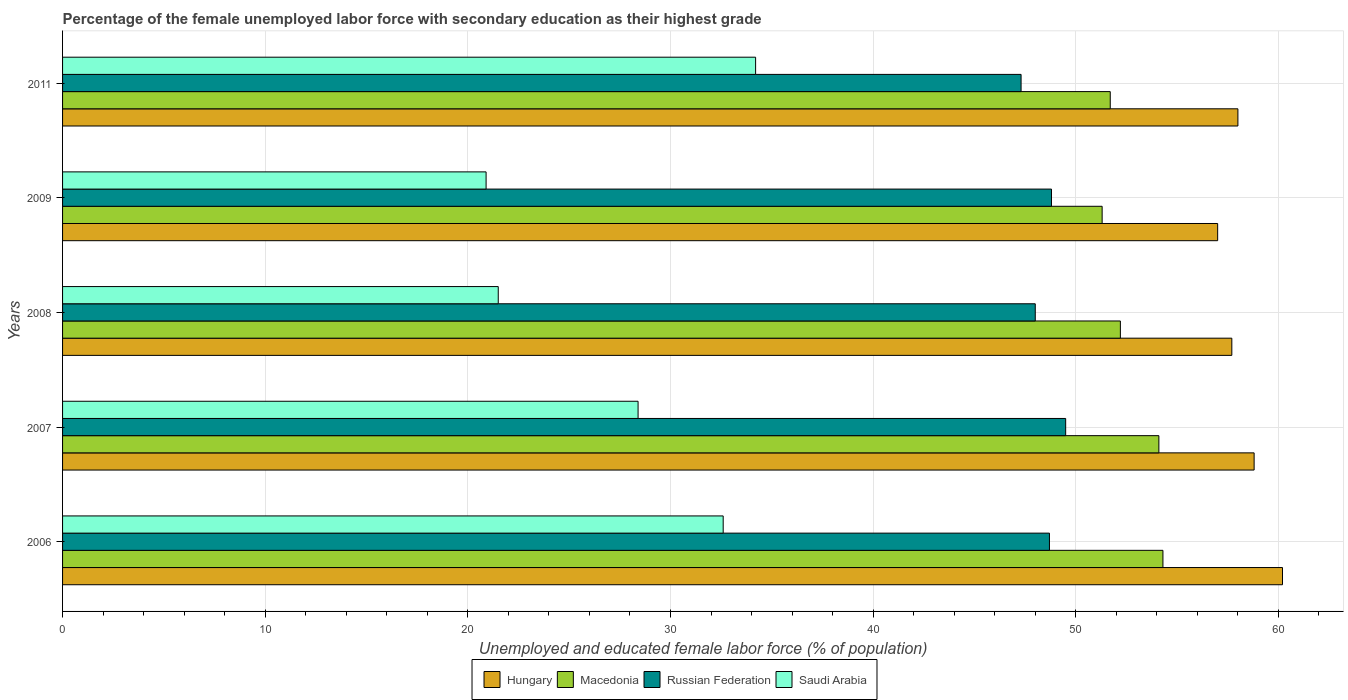How many different coloured bars are there?
Your answer should be very brief. 4. How many groups of bars are there?
Provide a succinct answer. 5. How many bars are there on the 5th tick from the top?
Your answer should be compact. 4. What is the label of the 4th group of bars from the top?
Give a very brief answer. 2007. What is the percentage of the unemployed female labor force with secondary education in Macedonia in 2011?
Your response must be concise. 51.7. Across all years, what is the maximum percentage of the unemployed female labor force with secondary education in Hungary?
Provide a succinct answer. 60.2. Across all years, what is the minimum percentage of the unemployed female labor force with secondary education in Macedonia?
Your answer should be very brief. 51.3. In which year was the percentage of the unemployed female labor force with secondary education in Hungary maximum?
Your answer should be compact. 2006. What is the total percentage of the unemployed female labor force with secondary education in Hungary in the graph?
Offer a terse response. 291.7. What is the difference between the percentage of the unemployed female labor force with secondary education in Russian Federation in 2008 and that in 2009?
Make the answer very short. -0.8. What is the difference between the percentage of the unemployed female labor force with secondary education in Saudi Arabia in 2006 and the percentage of the unemployed female labor force with secondary education in Hungary in 2008?
Offer a very short reply. -25.1. What is the average percentage of the unemployed female labor force with secondary education in Russian Federation per year?
Your answer should be compact. 48.46. In the year 2007, what is the difference between the percentage of the unemployed female labor force with secondary education in Russian Federation and percentage of the unemployed female labor force with secondary education in Saudi Arabia?
Your answer should be very brief. 21.1. What is the ratio of the percentage of the unemployed female labor force with secondary education in Saudi Arabia in 2006 to that in 2007?
Your answer should be very brief. 1.15. What is the difference between the highest and the second highest percentage of the unemployed female labor force with secondary education in Macedonia?
Provide a succinct answer. 0.2. What is the difference between the highest and the lowest percentage of the unemployed female labor force with secondary education in Saudi Arabia?
Make the answer very short. 13.3. In how many years, is the percentage of the unemployed female labor force with secondary education in Saudi Arabia greater than the average percentage of the unemployed female labor force with secondary education in Saudi Arabia taken over all years?
Make the answer very short. 3. Is it the case that in every year, the sum of the percentage of the unemployed female labor force with secondary education in Saudi Arabia and percentage of the unemployed female labor force with secondary education in Russian Federation is greater than the sum of percentage of the unemployed female labor force with secondary education in Hungary and percentage of the unemployed female labor force with secondary education in Macedonia?
Keep it short and to the point. Yes. What does the 2nd bar from the top in 2007 represents?
Your answer should be compact. Russian Federation. What does the 4th bar from the bottom in 2006 represents?
Offer a terse response. Saudi Arabia. What is the difference between two consecutive major ticks on the X-axis?
Ensure brevity in your answer.  10. Are the values on the major ticks of X-axis written in scientific E-notation?
Offer a very short reply. No. Does the graph contain any zero values?
Your answer should be very brief. No. Does the graph contain grids?
Ensure brevity in your answer.  Yes. Where does the legend appear in the graph?
Provide a short and direct response. Bottom center. How many legend labels are there?
Ensure brevity in your answer.  4. How are the legend labels stacked?
Your answer should be compact. Horizontal. What is the title of the graph?
Your answer should be compact. Percentage of the female unemployed labor force with secondary education as their highest grade. What is the label or title of the X-axis?
Keep it short and to the point. Unemployed and educated female labor force (% of population). What is the label or title of the Y-axis?
Ensure brevity in your answer.  Years. What is the Unemployed and educated female labor force (% of population) in Hungary in 2006?
Keep it short and to the point. 60.2. What is the Unemployed and educated female labor force (% of population) in Macedonia in 2006?
Keep it short and to the point. 54.3. What is the Unemployed and educated female labor force (% of population) in Russian Federation in 2006?
Give a very brief answer. 48.7. What is the Unemployed and educated female labor force (% of population) of Saudi Arabia in 2006?
Your answer should be compact. 32.6. What is the Unemployed and educated female labor force (% of population) in Hungary in 2007?
Your answer should be very brief. 58.8. What is the Unemployed and educated female labor force (% of population) in Macedonia in 2007?
Your response must be concise. 54.1. What is the Unemployed and educated female labor force (% of population) in Russian Federation in 2007?
Offer a terse response. 49.5. What is the Unemployed and educated female labor force (% of population) in Saudi Arabia in 2007?
Make the answer very short. 28.4. What is the Unemployed and educated female labor force (% of population) in Hungary in 2008?
Your answer should be compact. 57.7. What is the Unemployed and educated female labor force (% of population) of Macedonia in 2008?
Make the answer very short. 52.2. What is the Unemployed and educated female labor force (% of population) of Saudi Arabia in 2008?
Give a very brief answer. 21.5. What is the Unemployed and educated female labor force (% of population) of Macedonia in 2009?
Give a very brief answer. 51.3. What is the Unemployed and educated female labor force (% of population) in Russian Federation in 2009?
Your answer should be compact. 48.8. What is the Unemployed and educated female labor force (% of population) in Saudi Arabia in 2009?
Your answer should be very brief. 20.9. What is the Unemployed and educated female labor force (% of population) of Macedonia in 2011?
Give a very brief answer. 51.7. What is the Unemployed and educated female labor force (% of population) of Russian Federation in 2011?
Give a very brief answer. 47.3. What is the Unemployed and educated female labor force (% of population) of Saudi Arabia in 2011?
Provide a short and direct response. 34.2. Across all years, what is the maximum Unemployed and educated female labor force (% of population) in Hungary?
Give a very brief answer. 60.2. Across all years, what is the maximum Unemployed and educated female labor force (% of population) in Macedonia?
Ensure brevity in your answer.  54.3. Across all years, what is the maximum Unemployed and educated female labor force (% of population) of Russian Federation?
Your response must be concise. 49.5. Across all years, what is the maximum Unemployed and educated female labor force (% of population) in Saudi Arabia?
Make the answer very short. 34.2. Across all years, what is the minimum Unemployed and educated female labor force (% of population) of Macedonia?
Provide a short and direct response. 51.3. Across all years, what is the minimum Unemployed and educated female labor force (% of population) in Russian Federation?
Your answer should be compact. 47.3. Across all years, what is the minimum Unemployed and educated female labor force (% of population) of Saudi Arabia?
Give a very brief answer. 20.9. What is the total Unemployed and educated female labor force (% of population) in Hungary in the graph?
Ensure brevity in your answer.  291.7. What is the total Unemployed and educated female labor force (% of population) in Macedonia in the graph?
Your answer should be very brief. 263.6. What is the total Unemployed and educated female labor force (% of population) of Russian Federation in the graph?
Your answer should be very brief. 242.3. What is the total Unemployed and educated female labor force (% of population) in Saudi Arabia in the graph?
Offer a very short reply. 137.6. What is the difference between the Unemployed and educated female labor force (% of population) in Saudi Arabia in 2006 and that in 2007?
Keep it short and to the point. 4.2. What is the difference between the Unemployed and educated female labor force (% of population) in Hungary in 2006 and that in 2008?
Ensure brevity in your answer.  2.5. What is the difference between the Unemployed and educated female labor force (% of population) of Saudi Arabia in 2006 and that in 2008?
Provide a succinct answer. 11.1. What is the difference between the Unemployed and educated female labor force (% of population) of Hungary in 2006 and that in 2009?
Offer a very short reply. 3.2. What is the difference between the Unemployed and educated female labor force (% of population) in Russian Federation in 2006 and that in 2009?
Your response must be concise. -0.1. What is the difference between the Unemployed and educated female labor force (% of population) in Saudi Arabia in 2006 and that in 2009?
Ensure brevity in your answer.  11.7. What is the difference between the Unemployed and educated female labor force (% of population) of Hungary in 2006 and that in 2011?
Provide a short and direct response. 2.2. What is the difference between the Unemployed and educated female labor force (% of population) in Macedonia in 2007 and that in 2008?
Provide a short and direct response. 1.9. What is the difference between the Unemployed and educated female labor force (% of population) in Saudi Arabia in 2007 and that in 2008?
Your response must be concise. 6.9. What is the difference between the Unemployed and educated female labor force (% of population) in Hungary in 2007 and that in 2009?
Make the answer very short. 1.8. What is the difference between the Unemployed and educated female labor force (% of population) in Russian Federation in 2007 and that in 2009?
Your answer should be very brief. 0.7. What is the difference between the Unemployed and educated female labor force (% of population) of Russian Federation in 2007 and that in 2011?
Offer a terse response. 2.2. What is the difference between the Unemployed and educated female labor force (% of population) in Macedonia in 2008 and that in 2009?
Offer a terse response. 0.9. What is the difference between the Unemployed and educated female labor force (% of population) in Russian Federation in 2008 and that in 2009?
Make the answer very short. -0.8. What is the difference between the Unemployed and educated female labor force (% of population) of Macedonia in 2008 and that in 2011?
Ensure brevity in your answer.  0.5. What is the difference between the Unemployed and educated female labor force (% of population) in Saudi Arabia in 2008 and that in 2011?
Provide a short and direct response. -12.7. What is the difference between the Unemployed and educated female labor force (% of population) in Hungary in 2006 and the Unemployed and educated female labor force (% of population) in Macedonia in 2007?
Offer a terse response. 6.1. What is the difference between the Unemployed and educated female labor force (% of population) of Hungary in 2006 and the Unemployed and educated female labor force (% of population) of Russian Federation in 2007?
Give a very brief answer. 10.7. What is the difference between the Unemployed and educated female labor force (% of population) of Hungary in 2006 and the Unemployed and educated female labor force (% of population) of Saudi Arabia in 2007?
Keep it short and to the point. 31.8. What is the difference between the Unemployed and educated female labor force (% of population) of Macedonia in 2006 and the Unemployed and educated female labor force (% of population) of Russian Federation in 2007?
Offer a terse response. 4.8. What is the difference between the Unemployed and educated female labor force (% of population) in Macedonia in 2006 and the Unemployed and educated female labor force (% of population) in Saudi Arabia in 2007?
Your answer should be compact. 25.9. What is the difference between the Unemployed and educated female labor force (% of population) in Russian Federation in 2006 and the Unemployed and educated female labor force (% of population) in Saudi Arabia in 2007?
Offer a very short reply. 20.3. What is the difference between the Unemployed and educated female labor force (% of population) of Hungary in 2006 and the Unemployed and educated female labor force (% of population) of Macedonia in 2008?
Your answer should be compact. 8. What is the difference between the Unemployed and educated female labor force (% of population) in Hungary in 2006 and the Unemployed and educated female labor force (% of population) in Saudi Arabia in 2008?
Your answer should be very brief. 38.7. What is the difference between the Unemployed and educated female labor force (% of population) of Macedonia in 2006 and the Unemployed and educated female labor force (% of population) of Russian Federation in 2008?
Your answer should be compact. 6.3. What is the difference between the Unemployed and educated female labor force (% of population) in Macedonia in 2006 and the Unemployed and educated female labor force (% of population) in Saudi Arabia in 2008?
Make the answer very short. 32.8. What is the difference between the Unemployed and educated female labor force (% of population) in Russian Federation in 2006 and the Unemployed and educated female labor force (% of population) in Saudi Arabia in 2008?
Keep it short and to the point. 27.2. What is the difference between the Unemployed and educated female labor force (% of population) of Hungary in 2006 and the Unemployed and educated female labor force (% of population) of Saudi Arabia in 2009?
Provide a succinct answer. 39.3. What is the difference between the Unemployed and educated female labor force (% of population) in Macedonia in 2006 and the Unemployed and educated female labor force (% of population) in Saudi Arabia in 2009?
Your answer should be very brief. 33.4. What is the difference between the Unemployed and educated female labor force (% of population) in Russian Federation in 2006 and the Unemployed and educated female labor force (% of population) in Saudi Arabia in 2009?
Offer a very short reply. 27.8. What is the difference between the Unemployed and educated female labor force (% of population) of Hungary in 2006 and the Unemployed and educated female labor force (% of population) of Macedonia in 2011?
Your response must be concise. 8.5. What is the difference between the Unemployed and educated female labor force (% of population) of Macedonia in 2006 and the Unemployed and educated female labor force (% of population) of Saudi Arabia in 2011?
Provide a succinct answer. 20.1. What is the difference between the Unemployed and educated female labor force (% of population) in Hungary in 2007 and the Unemployed and educated female labor force (% of population) in Russian Federation in 2008?
Ensure brevity in your answer.  10.8. What is the difference between the Unemployed and educated female labor force (% of population) in Hungary in 2007 and the Unemployed and educated female labor force (% of population) in Saudi Arabia in 2008?
Offer a very short reply. 37.3. What is the difference between the Unemployed and educated female labor force (% of population) in Macedonia in 2007 and the Unemployed and educated female labor force (% of population) in Russian Federation in 2008?
Your answer should be very brief. 6.1. What is the difference between the Unemployed and educated female labor force (% of population) of Macedonia in 2007 and the Unemployed and educated female labor force (% of population) of Saudi Arabia in 2008?
Make the answer very short. 32.6. What is the difference between the Unemployed and educated female labor force (% of population) in Russian Federation in 2007 and the Unemployed and educated female labor force (% of population) in Saudi Arabia in 2008?
Offer a very short reply. 28. What is the difference between the Unemployed and educated female labor force (% of population) of Hungary in 2007 and the Unemployed and educated female labor force (% of population) of Macedonia in 2009?
Make the answer very short. 7.5. What is the difference between the Unemployed and educated female labor force (% of population) of Hungary in 2007 and the Unemployed and educated female labor force (% of population) of Saudi Arabia in 2009?
Your response must be concise. 37.9. What is the difference between the Unemployed and educated female labor force (% of population) of Macedonia in 2007 and the Unemployed and educated female labor force (% of population) of Russian Federation in 2009?
Ensure brevity in your answer.  5.3. What is the difference between the Unemployed and educated female labor force (% of population) in Macedonia in 2007 and the Unemployed and educated female labor force (% of population) in Saudi Arabia in 2009?
Offer a very short reply. 33.2. What is the difference between the Unemployed and educated female labor force (% of population) in Russian Federation in 2007 and the Unemployed and educated female labor force (% of population) in Saudi Arabia in 2009?
Your answer should be very brief. 28.6. What is the difference between the Unemployed and educated female labor force (% of population) in Hungary in 2007 and the Unemployed and educated female labor force (% of population) in Macedonia in 2011?
Your answer should be very brief. 7.1. What is the difference between the Unemployed and educated female labor force (% of population) of Hungary in 2007 and the Unemployed and educated female labor force (% of population) of Russian Federation in 2011?
Keep it short and to the point. 11.5. What is the difference between the Unemployed and educated female labor force (% of population) in Hungary in 2007 and the Unemployed and educated female labor force (% of population) in Saudi Arabia in 2011?
Your response must be concise. 24.6. What is the difference between the Unemployed and educated female labor force (% of population) of Macedonia in 2007 and the Unemployed and educated female labor force (% of population) of Saudi Arabia in 2011?
Your response must be concise. 19.9. What is the difference between the Unemployed and educated female labor force (% of population) in Hungary in 2008 and the Unemployed and educated female labor force (% of population) in Saudi Arabia in 2009?
Your answer should be very brief. 36.8. What is the difference between the Unemployed and educated female labor force (% of population) of Macedonia in 2008 and the Unemployed and educated female labor force (% of population) of Russian Federation in 2009?
Make the answer very short. 3.4. What is the difference between the Unemployed and educated female labor force (% of population) of Macedonia in 2008 and the Unemployed and educated female labor force (% of population) of Saudi Arabia in 2009?
Give a very brief answer. 31.3. What is the difference between the Unemployed and educated female labor force (% of population) in Russian Federation in 2008 and the Unemployed and educated female labor force (% of population) in Saudi Arabia in 2009?
Provide a short and direct response. 27.1. What is the difference between the Unemployed and educated female labor force (% of population) of Hungary in 2008 and the Unemployed and educated female labor force (% of population) of Saudi Arabia in 2011?
Provide a succinct answer. 23.5. What is the difference between the Unemployed and educated female labor force (% of population) in Macedonia in 2008 and the Unemployed and educated female labor force (% of population) in Russian Federation in 2011?
Provide a short and direct response. 4.9. What is the difference between the Unemployed and educated female labor force (% of population) in Russian Federation in 2008 and the Unemployed and educated female labor force (% of population) in Saudi Arabia in 2011?
Provide a succinct answer. 13.8. What is the difference between the Unemployed and educated female labor force (% of population) of Hungary in 2009 and the Unemployed and educated female labor force (% of population) of Macedonia in 2011?
Your response must be concise. 5.3. What is the difference between the Unemployed and educated female labor force (% of population) in Hungary in 2009 and the Unemployed and educated female labor force (% of population) in Russian Federation in 2011?
Offer a very short reply. 9.7. What is the difference between the Unemployed and educated female labor force (% of population) in Hungary in 2009 and the Unemployed and educated female labor force (% of population) in Saudi Arabia in 2011?
Provide a succinct answer. 22.8. What is the difference between the Unemployed and educated female labor force (% of population) in Macedonia in 2009 and the Unemployed and educated female labor force (% of population) in Saudi Arabia in 2011?
Your response must be concise. 17.1. What is the average Unemployed and educated female labor force (% of population) in Hungary per year?
Provide a succinct answer. 58.34. What is the average Unemployed and educated female labor force (% of population) in Macedonia per year?
Ensure brevity in your answer.  52.72. What is the average Unemployed and educated female labor force (% of population) in Russian Federation per year?
Provide a short and direct response. 48.46. What is the average Unemployed and educated female labor force (% of population) of Saudi Arabia per year?
Keep it short and to the point. 27.52. In the year 2006, what is the difference between the Unemployed and educated female labor force (% of population) in Hungary and Unemployed and educated female labor force (% of population) in Saudi Arabia?
Keep it short and to the point. 27.6. In the year 2006, what is the difference between the Unemployed and educated female labor force (% of population) in Macedonia and Unemployed and educated female labor force (% of population) in Saudi Arabia?
Your answer should be very brief. 21.7. In the year 2006, what is the difference between the Unemployed and educated female labor force (% of population) in Russian Federation and Unemployed and educated female labor force (% of population) in Saudi Arabia?
Give a very brief answer. 16.1. In the year 2007, what is the difference between the Unemployed and educated female labor force (% of population) of Hungary and Unemployed and educated female labor force (% of population) of Macedonia?
Make the answer very short. 4.7. In the year 2007, what is the difference between the Unemployed and educated female labor force (% of population) in Hungary and Unemployed and educated female labor force (% of population) in Russian Federation?
Offer a terse response. 9.3. In the year 2007, what is the difference between the Unemployed and educated female labor force (% of population) of Hungary and Unemployed and educated female labor force (% of population) of Saudi Arabia?
Offer a terse response. 30.4. In the year 2007, what is the difference between the Unemployed and educated female labor force (% of population) of Macedonia and Unemployed and educated female labor force (% of population) of Russian Federation?
Your response must be concise. 4.6. In the year 2007, what is the difference between the Unemployed and educated female labor force (% of population) of Macedonia and Unemployed and educated female labor force (% of population) of Saudi Arabia?
Make the answer very short. 25.7. In the year 2007, what is the difference between the Unemployed and educated female labor force (% of population) of Russian Federation and Unemployed and educated female labor force (% of population) of Saudi Arabia?
Give a very brief answer. 21.1. In the year 2008, what is the difference between the Unemployed and educated female labor force (% of population) in Hungary and Unemployed and educated female labor force (% of population) in Macedonia?
Keep it short and to the point. 5.5. In the year 2008, what is the difference between the Unemployed and educated female labor force (% of population) of Hungary and Unemployed and educated female labor force (% of population) of Russian Federation?
Provide a short and direct response. 9.7. In the year 2008, what is the difference between the Unemployed and educated female labor force (% of population) of Hungary and Unemployed and educated female labor force (% of population) of Saudi Arabia?
Your answer should be compact. 36.2. In the year 2008, what is the difference between the Unemployed and educated female labor force (% of population) of Macedonia and Unemployed and educated female labor force (% of population) of Russian Federation?
Your response must be concise. 4.2. In the year 2008, what is the difference between the Unemployed and educated female labor force (% of population) in Macedonia and Unemployed and educated female labor force (% of population) in Saudi Arabia?
Your response must be concise. 30.7. In the year 2008, what is the difference between the Unemployed and educated female labor force (% of population) of Russian Federation and Unemployed and educated female labor force (% of population) of Saudi Arabia?
Provide a succinct answer. 26.5. In the year 2009, what is the difference between the Unemployed and educated female labor force (% of population) in Hungary and Unemployed and educated female labor force (% of population) in Macedonia?
Provide a succinct answer. 5.7. In the year 2009, what is the difference between the Unemployed and educated female labor force (% of population) in Hungary and Unemployed and educated female labor force (% of population) in Russian Federation?
Your response must be concise. 8.2. In the year 2009, what is the difference between the Unemployed and educated female labor force (% of population) of Hungary and Unemployed and educated female labor force (% of population) of Saudi Arabia?
Provide a succinct answer. 36.1. In the year 2009, what is the difference between the Unemployed and educated female labor force (% of population) of Macedonia and Unemployed and educated female labor force (% of population) of Russian Federation?
Your response must be concise. 2.5. In the year 2009, what is the difference between the Unemployed and educated female labor force (% of population) in Macedonia and Unemployed and educated female labor force (% of population) in Saudi Arabia?
Your response must be concise. 30.4. In the year 2009, what is the difference between the Unemployed and educated female labor force (% of population) of Russian Federation and Unemployed and educated female labor force (% of population) of Saudi Arabia?
Give a very brief answer. 27.9. In the year 2011, what is the difference between the Unemployed and educated female labor force (% of population) of Hungary and Unemployed and educated female labor force (% of population) of Macedonia?
Keep it short and to the point. 6.3. In the year 2011, what is the difference between the Unemployed and educated female labor force (% of population) in Hungary and Unemployed and educated female labor force (% of population) in Saudi Arabia?
Your answer should be very brief. 23.8. In the year 2011, what is the difference between the Unemployed and educated female labor force (% of population) in Macedonia and Unemployed and educated female labor force (% of population) in Russian Federation?
Make the answer very short. 4.4. In the year 2011, what is the difference between the Unemployed and educated female labor force (% of population) in Macedonia and Unemployed and educated female labor force (% of population) in Saudi Arabia?
Ensure brevity in your answer.  17.5. In the year 2011, what is the difference between the Unemployed and educated female labor force (% of population) in Russian Federation and Unemployed and educated female labor force (% of population) in Saudi Arabia?
Offer a very short reply. 13.1. What is the ratio of the Unemployed and educated female labor force (% of population) in Hungary in 2006 to that in 2007?
Ensure brevity in your answer.  1.02. What is the ratio of the Unemployed and educated female labor force (% of population) of Russian Federation in 2006 to that in 2007?
Give a very brief answer. 0.98. What is the ratio of the Unemployed and educated female labor force (% of population) of Saudi Arabia in 2006 to that in 2007?
Offer a terse response. 1.15. What is the ratio of the Unemployed and educated female labor force (% of population) of Hungary in 2006 to that in 2008?
Your response must be concise. 1.04. What is the ratio of the Unemployed and educated female labor force (% of population) in Macedonia in 2006 to that in 2008?
Keep it short and to the point. 1.04. What is the ratio of the Unemployed and educated female labor force (% of population) in Russian Federation in 2006 to that in 2008?
Give a very brief answer. 1.01. What is the ratio of the Unemployed and educated female labor force (% of population) in Saudi Arabia in 2006 to that in 2008?
Your response must be concise. 1.52. What is the ratio of the Unemployed and educated female labor force (% of population) in Hungary in 2006 to that in 2009?
Keep it short and to the point. 1.06. What is the ratio of the Unemployed and educated female labor force (% of population) in Macedonia in 2006 to that in 2009?
Offer a very short reply. 1.06. What is the ratio of the Unemployed and educated female labor force (% of population) in Saudi Arabia in 2006 to that in 2009?
Your answer should be compact. 1.56. What is the ratio of the Unemployed and educated female labor force (% of population) of Hungary in 2006 to that in 2011?
Your answer should be very brief. 1.04. What is the ratio of the Unemployed and educated female labor force (% of population) of Macedonia in 2006 to that in 2011?
Your response must be concise. 1.05. What is the ratio of the Unemployed and educated female labor force (% of population) of Russian Federation in 2006 to that in 2011?
Ensure brevity in your answer.  1.03. What is the ratio of the Unemployed and educated female labor force (% of population) in Saudi Arabia in 2006 to that in 2011?
Provide a succinct answer. 0.95. What is the ratio of the Unemployed and educated female labor force (% of population) of Hungary in 2007 to that in 2008?
Keep it short and to the point. 1.02. What is the ratio of the Unemployed and educated female labor force (% of population) of Macedonia in 2007 to that in 2008?
Keep it short and to the point. 1.04. What is the ratio of the Unemployed and educated female labor force (% of population) in Russian Federation in 2007 to that in 2008?
Offer a terse response. 1.03. What is the ratio of the Unemployed and educated female labor force (% of population) in Saudi Arabia in 2007 to that in 2008?
Offer a terse response. 1.32. What is the ratio of the Unemployed and educated female labor force (% of population) in Hungary in 2007 to that in 2009?
Give a very brief answer. 1.03. What is the ratio of the Unemployed and educated female labor force (% of population) of Macedonia in 2007 to that in 2009?
Your answer should be very brief. 1.05. What is the ratio of the Unemployed and educated female labor force (% of population) of Russian Federation in 2007 to that in 2009?
Provide a succinct answer. 1.01. What is the ratio of the Unemployed and educated female labor force (% of population) in Saudi Arabia in 2007 to that in 2009?
Keep it short and to the point. 1.36. What is the ratio of the Unemployed and educated female labor force (% of population) of Hungary in 2007 to that in 2011?
Offer a terse response. 1.01. What is the ratio of the Unemployed and educated female labor force (% of population) in Macedonia in 2007 to that in 2011?
Your response must be concise. 1.05. What is the ratio of the Unemployed and educated female labor force (% of population) in Russian Federation in 2007 to that in 2011?
Your response must be concise. 1.05. What is the ratio of the Unemployed and educated female labor force (% of population) in Saudi Arabia in 2007 to that in 2011?
Your answer should be very brief. 0.83. What is the ratio of the Unemployed and educated female labor force (% of population) of Hungary in 2008 to that in 2009?
Your answer should be compact. 1.01. What is the ratio of the Unemployed and educated female labor force (% of population) of Macedonia in 2008 to that in 2009?
Provide a succinct answer. 1.02. What is the ratio of the Unemployed and educated female labor force (% of population) of Russian Federation in 2008 to that in 2009?
Provide a short and direct response. 0.98. What is the ratio of the Unemployed and educated female labor force (% of population) of Saudi Arabia in 2008 to that in 2009?
Your answer should be very brief. 1.03. What is the ratio of the Unemployed and educated female labor force (% of population) in Macedonia in 2008 to that in 2011?
Your answer should be compact. 1.01. What is the ratio of the Unemployed and educated female labor force (% of population) of Russian Federation in 2008 to that in 2011?
Your answer should be very brief. 1.01. What is the ratio of the Unemployed and educated female labor force (% of population) of Saudi Arabia in 2008 to that in 2011?
Offer a very short reply. 0.63. What is the ratio of the Unemployed and educated female labor force (% of population) of Hungary in 2009 to that in 2011?
Your answer should be very brief. 0.98. What is the ratio of the Unemployed and educated female labor force (% of population) in Macedonia in 2009 to that in 2011?
Ensure brevity in your answer.  0.99. What is the ratio of the Unemployed and educated female labor force (% of population) of Russian Federation in 2009 to that in 2011?
Ensure brevity in your answer.  1.03. What is the ratio of the Unemployed and educated female labor force (% of population) in Saudi Arabia in 2009 to that in 2011?
Your answer should be compact. 0.61. What is the difference between the highest and the second highest Unemployed and educated female labor force (% of population) of Saudi Arabia?
Give a very brief answer. 1.6. What is the difference between the highest and the lowest Unemployed and educated female labor force (% of population) in Hungary?
Provide a succinct answer. 3.2. What is the difference between the highest and the lowest Unemployed and educated female labor force (% of population) in Russian Federation?
Your response must be concise. 2.2. What is the difference between the highest and the lowest Unemployed and educated female labor force (% of population) in Saudi Arabia?
Offer a terse response. 13.3. 